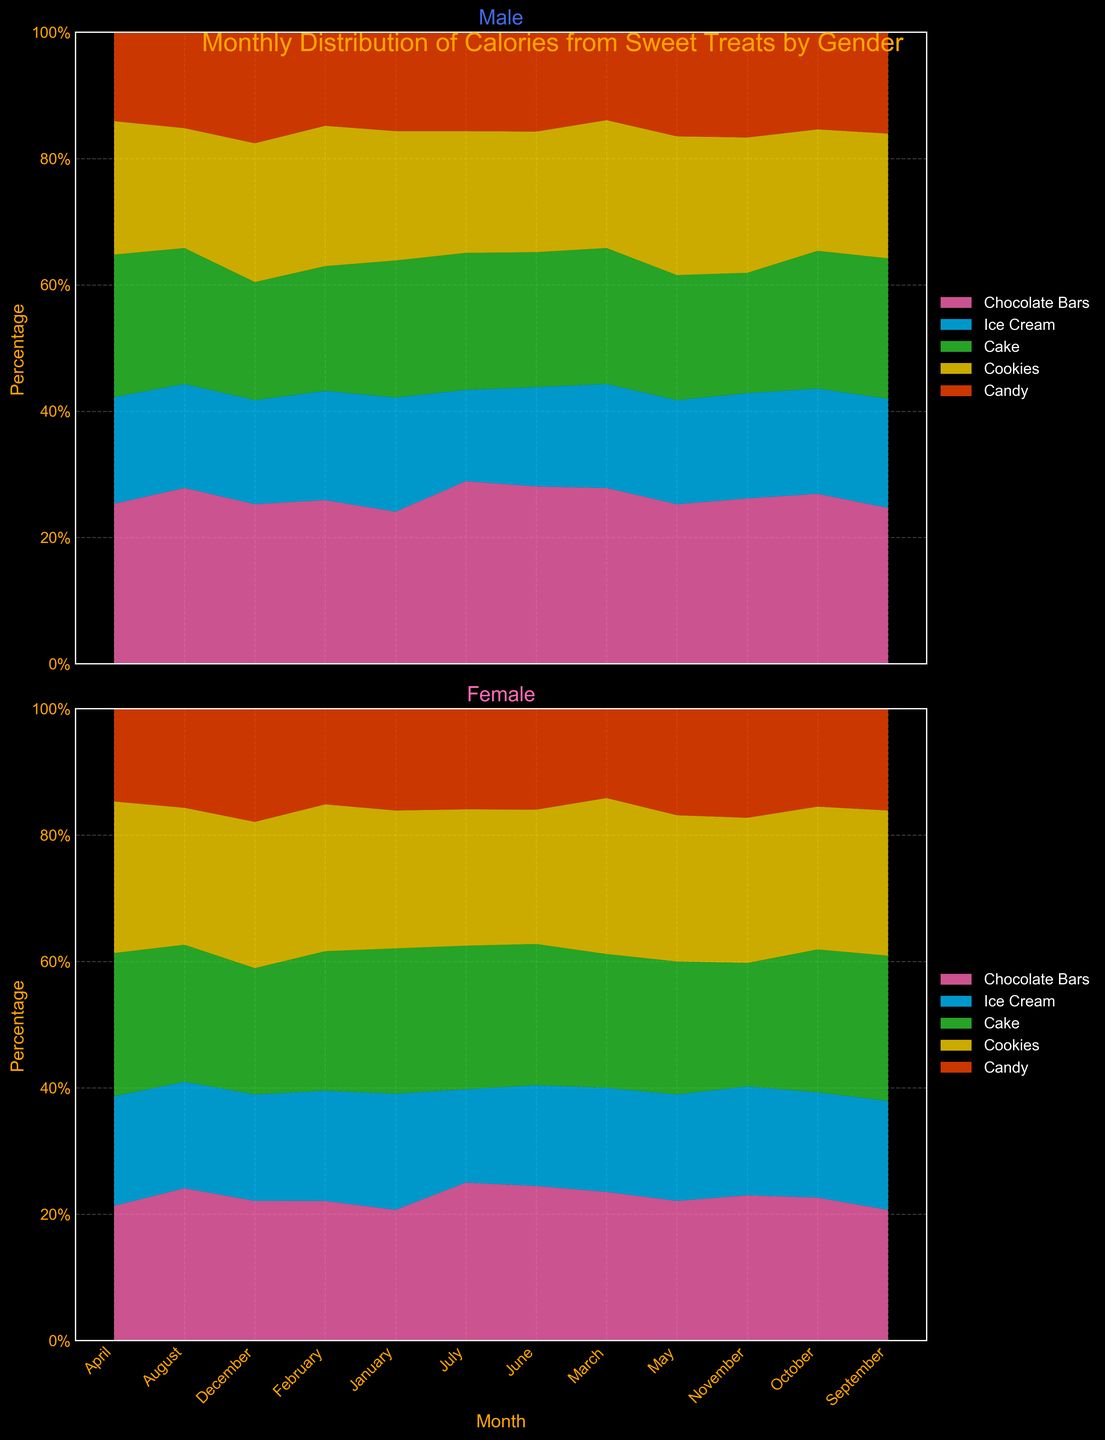What is the title of the figure? The title of the figure is usually found at the top and it describes the overall content and purpose of the visualization. Here, the title is provided at the top of the figure.
Answer: Monthly Distribution of Calories from Sweet Treats by Gender How many categories of sweet treats are shown in the figure? The figure contains different colored regions for each category of sweet treats. By counting these distinct regions in the legend, we can determine the number of categories.
Answer: 5 Which sweet treat category has the highest percentage for males in January? We need to observe the stack corresponding to January in the male subplot and identify which color region (representing a category) is the largest.
Answer: Chocolate Bars In which month do females consume the highest percentage of Ice Cream calories? This requires checking the female subplot and finding the month where the light blue color (representing Ice Cream) occupies the largest proportion of the stack.
Answer: May Which gender consumes a higher percentage of calories from Cake in June? Compare the Cake segments (green color) in both subplots for June. The one with a larger proportion indicates the higher consumption.
Answer: Female What is the lowest percentage of Candy consumption for males, and in which month? Examine the male subplot and identify the stack where the orange-red section (representing Candy) is the smallest.
Answer: March, 10% Overall, do males or females have a higher fluctuation in the percentage of calorie consumption from Cookies? This requires analyzing and comparing the variance in the purple regions (representing Cookies) across months for both genders.
Answer: Females Which month shows the smallest percentage of consumption for Chocolate Bars among females? Look at the female subplot and find the month with the smallest pink section (representing Chocolate Bars) in the stack for each month.
Answer: April How does the distribution of calorie consumption from Ice Cream change over the months for males? Observe the light blue regions for males across all months, noting any increasing or decreasing trends, or periods of stability.
Answer: Generally decreases In December, which gender has a higher percentage of calorie intake from Candy? Compare the orange-red areas for December in both the male and female subplots to determine which is larger.
Answer: Female 